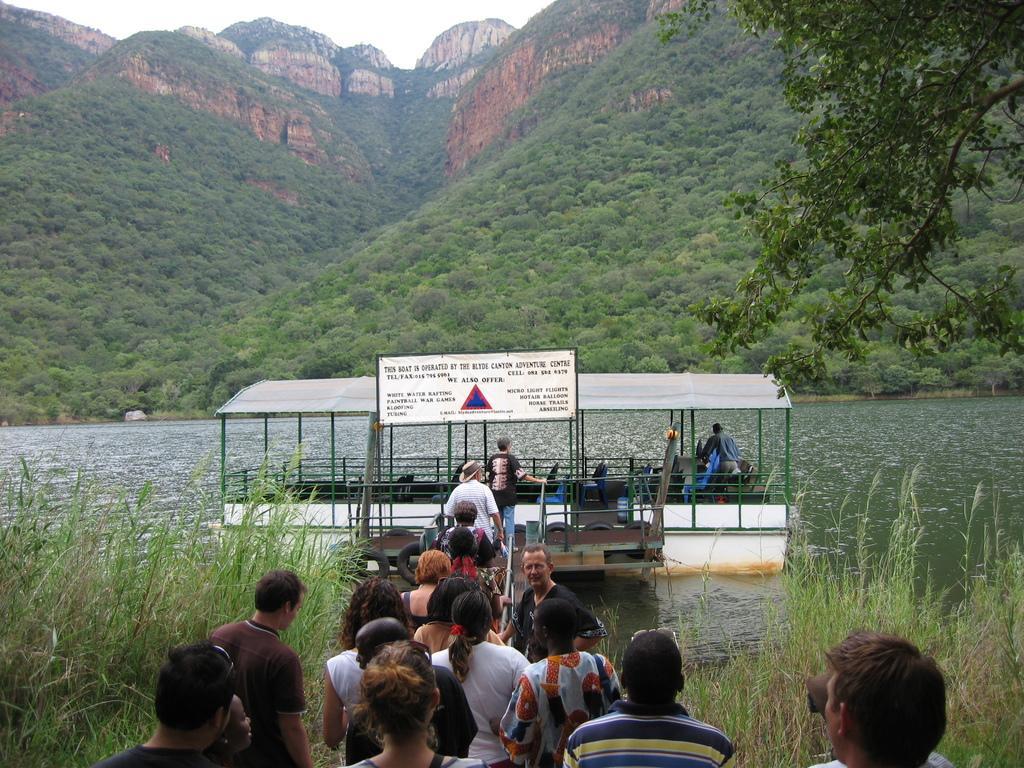Describe this image in one or two sentences. In this picture we can see a few people. We can see some grass on the right and left side of the image. There is the water. We can see a person, seats and other things on the boat visible in the water. We can see a few plants and some mountains in the background. There is a planet visible in the top right. 